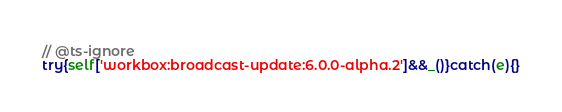Convert code to text. <code><loc_0><loc_0><loc_500><loc_500><_TypeScript_>// @ts-ignore
try{self['workbox:broadcast-update:6.0.0-alpha.2']&&_()}catch(e){}</code> 